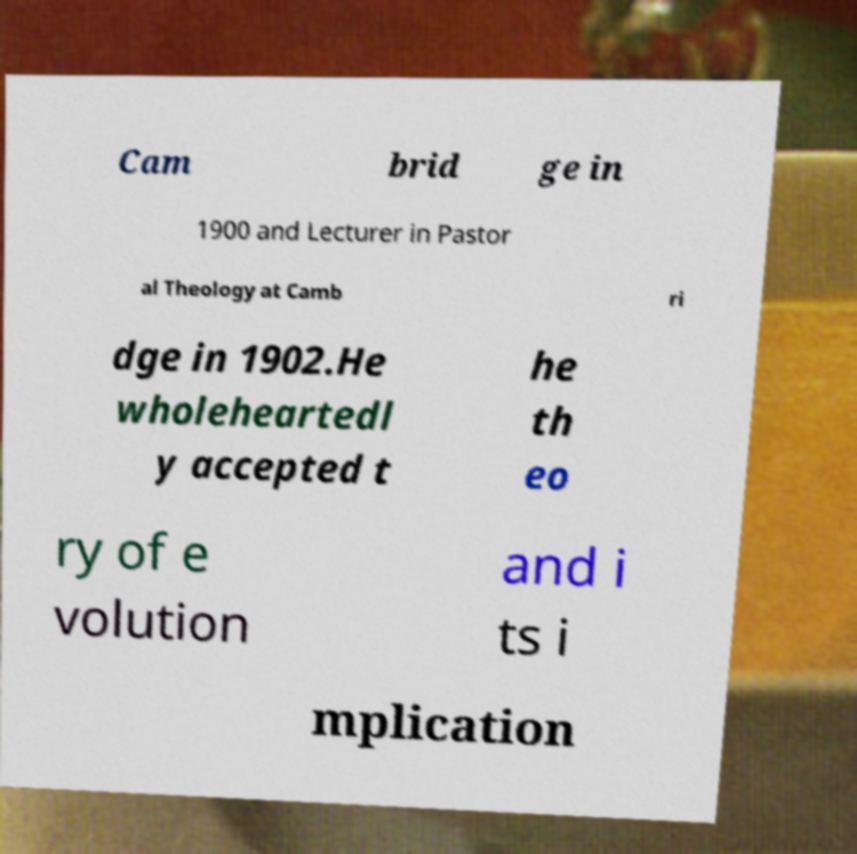Can you accurately transcribe the text from the provided image for me? Cam brid ge in 1900 and Lecturer in Pastor al Theology at Camb ri dge in 1902.He wholeheartedl y accepted t he th eo ry of e volution and i ts i mplication 